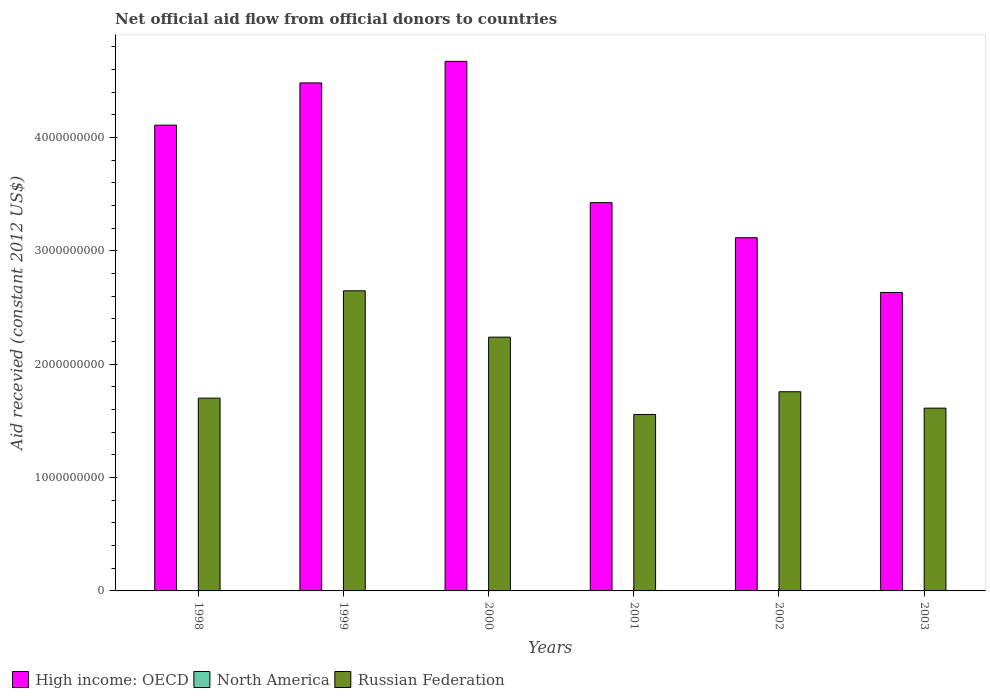Are the number of bars per tick equal to the number of legend labels?
Your answer should be very brief. Yes. What is the total aid received in High income: OECD in 1999?
Give a very brief answer. 4.48e+09. Across all years, what is the maximum total aid received in North America?
Offer a terse response. 7.40e+05. In which year was the total aid received in Russian Federation maximum?
Provide a short and direct response. 1999. In which year was the total aid received in Russian Federation minimum?
Your response must be concise. 2001. What is the total total aid received in North America in the graph?
Give a very brief answer. 1.09e+06. What is the difference between the total aid received in Russian Federation in 2002 and the total aid received in High income: OECD in 1999?
Offer a very short reply. -2.73e+09. What is the average total aid received in North America per year?
Give a very brief answer. 1.82e+05. In the year 1998, what is the difference between the total aid received in Russian Federation and total aid received in North America?
Make the answer very short. 1.70e+09. In how many years, is the total aid received in Russian Federation greater than 4000000000 US$?
Make the answer very short. 0. What is the ratio of the total aid received in Russian Federation in 1999 to that in 2000?
Your answer should be very brief. 1.18. What is the difference between the highest and the second highest total aid received in North America?
Make the answer very short. 6.10e+05. What is the difference between the highest and the lowest total aid received in High income: OECD?
Your answer should be compact. 2.04e+09. What does the 3rd bar from the left in 1999 represents?
Provide a succinct answer. Russian Federation. How many bars are there?
Ensure brevity in your answer.  18. Are all the bars in the graph horizontal?
Provide a succinct answer. No. What is the difference between two consecutive major ticks on the Y-axis?
Provide a succinct answer. 1.00e+09. Does the graph contain any zero values?
Offer a terse response. No. Where does the legend appear in the graph?
Offer a terse response. Bottom left. What is the title of the graph?
Give a very brief answer. Net official aid flow from official donors to countries. What is the label or title of the Y-axis?
Keep it short and to the point. Aid recevied (constant 2012 US$). What is the Aid recevied (constant 2012 US$) in High income: OECD in 1998?
Your answer should be very brief. 4.11e+09. What is the Aid recevied (constant 2012 US$) in North America in 1998?
Make the answer very short. 7.40e+05. What is the Aid recevied (constant 2012 US$) of Russian Federation in 1998?
Offer a terse response. 1.70e+09. What is the Aid recevied (constant 2012 US$) in High income: OECD in 1999?
Your answer should be compact. 4.48e+09. What is the Aid recevied (constant 2012 US$) of North America in 1999?
Your answer should be compact. 1.30e+05. What is the Aid recevied (constant 2012 US$) of Russian Federation in 1999?
Your answer should be compact. 2.65e+09. What is the Aid recevied (constant 2012 US$) of High income: OECD in 2000?
Your answer should be compact. 4.67e+09. What is the Aid recevied (constant 2012 US$) of North America in 2000?
Give a very brief answer. 1.10e+05. What is the Aid recevied (constant 2012 US$) in Russian Federation in 2000?
Provide a short and direct response. 2.24e+09. What is the Aid recevied (constant 2012 US$) in High income: OECD in 2001?
Offer a very short reply. 3.43e+09. What is the Aid recevied (constant 2012 US$) of Russian Federation in 2001?
Your answer should be very brief. 1.56e+09. What is the Aid recevied (constant 2012 US$) of High income: OECD in 2002?
Your response must be concise. 3.12e+09. What is the Aid recevied (constant 2012 US$) of North America in 2002?
Offer a terse response. 3.00e+04. What is the Aid recevied (constant 2012 US$) in Russian Federation in 2002?
Make the answer very short. 1.76e+09. What is the Aid recevied (constant 2012 US$) of High income: OECD in 2003?
Your response must be concise. 2.63e+09. What is the Aid recevied (constant 2012 US$) of Russian Federation in 2003?
Make the answer very short. 1.61e+09. Across all years, what is the maximum Aid recevied (constant 2012 US$) in High income: OECD?
Keep it short and to the point. 4.67e+09. Across all years, what is the maximum Aid recevied (constant 2012 US$) of North America?
Your answer should be compact. 7.40e+05. Across all years, what is the maximum Aid recevied (constant 2012 US$) of Russian Federation?
Offer a terse response. 2.65e+09. Across all years, what is the minimum Aid recevied (constant 2012 US$) in High income: OECD?
Make the answer very short. 2.63e+09. Across all years, what is the minimum Aid recevied (constant 2012 US$) of Russian Federation?
Provide a short and direct response. 1.56e+09. What is the total Aid recevied (constant 2012 US$) in High income: OECD in the graph?
Give a very brief answer. 2.24e+1. What is the total Aid recevied (constant 2012 US$) in North America in the graph?
Offer a very short reply. 1.09e+06. What is the total Aid recevied (constant 2012 US$) in Russian Federation in the graph?
Keep it short and to the point. 1.15e+1. What is the difference between the Aid recevied (constant 2012 US$) in High income: OECD in 1998 and that in 1999?
Provide a succinct answer. -3.73e+08. What is the difference between the Aid recevied (constant 2012 US$) in Russian Federation in 1998 and that in 1999?
Provide a short and direct response. -9.47e+08. What is the difference between the Aid recevied (constant 2012 US$) of High income: OECD in 1998 and that in 2000?
Provide a succinct answer. -5.63e+08. What is the difference between the Aid recevied (constant 2012 US$) of North America in 1998 and that in 2000?
Give a very brief answer. 6.30e+05. What is the difference between the Aid recevied (constant 2012 US$) in Russian Federation in 1998 and that in 2000?
Give a very brief answer. -5.38e+08. What is the difference between the Aid recevied (constant 2012 US$) of High income: OECD in 1998 and that in 2001?
Your response must be concise. 6.84e+08. What is the difference between the Aid recevied (constant 2012 US$) in North America in 1998 and that in 2001?
Provide a short and direct response. 7.00e+05. What is the difference between the Aid recevied (constant 2012 US$) in Russian Federation in 1998 and that in 2001?
Your response must be concise. 1.44e+08. What is the difference between the Aid recevied (constant 2012 US$) in High income: OECD in 1998 and that in 2002?
Offer a very short reply. 9.93e+08. What is the difference between the Aid recevied (constant 2012 US$) in North America in 1998 and that in 2002?
Your response must be concise. 7.10e+05. What is the difference between the Aid recevied (constant 2012 US$) in Russian Federation in 1998 and that in 2002?
Provide a short and direct response. -5.68e+07. What is the difference between the Aid recevied (constant 2012 US$) of High income: OECD in 1998 and that in 2003?
Keep it short and to the point. 1.48e+09. What is the difference between the Aid recevied (constant 2012 US$) of Russian Federation in 1998 and that in 2003?
Your answer should be compact. 8.80e+07. What is the difference between the Aid recevied (constant 2012 US$) of High income: OECD in 1999 and that in 2000?
Offer a terse response. -1.90e+08. What is the difference between the Aid recevied (constant 2012 US$) in North America in 1999 and that in 2000?
Make the answer very short. 2.00e+04. What is the difference between the Aid recevied (constant 2012 US$) of Russian Federation in 1999 and that in 2000?
Keep it short and to the point. 4.09e+08. What is the difference between the Aid recevied (constant 2012 US$) of High income: OECD in 1999 and that in 2001?
Offer a terse response. 1.06e+09. What is the difference between the Aid recevied (constant 2012 US$) of Russian Federation in 1999 and that in 2001?
Your response must be concise. 1.09e+09. What is the difference between the Aid recevied (constant 2012 US$) in High income: OECD in 1999 and that in 2002?
Keep it short and to the point. 1.37e+09. What is the difference between the Aid recevied (constant 2012 US$) of North America in 1999 and that in 2002?
Provide a succinct answer. 1.00e+05. What is the difference between the Aid recevied (constant 2012 US$) in Russian Federation in 1999 and that in 2002?
Provide a succinct answer. 8.90e+08. What is the difference between the Aid recevied (constant 2012 US$) in High income: OECD in 1999 and that in 2003?
Your answer should be very brief. 1.85e+09. What is the difference between the Aid recevied (constant 2012 US$) of North America in 1999 and that in 2003?
Your answer should be compact. 9.00e+04. What is the difference between the Aid recevied (constant 2012 US$) in Russian Federation in 1999 and that in 2003?
Ensure brevity in your answer.  1.04e+09. What is the difference between the Aid recevied (constant 2012 US$) of High income: OECD in 2000 and that in 2001?
Your answer should be very brief. 1.25e+09. What is the difference between the Aid recevied (constant 2012 US$) in North America in 2000 and that in 2001?
Your answer should be compact. 7.00e+04. What is the difference between the Aid recevied (constant 2012 US$) of Russian Federation in 2000 and that in 2001?
Your response must be concise. 6.83e+08. What is the difference between the Aid recevied (constant 2012 US$) of High income: OECD in 2000 and that in 2002?
Keep it short and to the point. 1.56e+09. What is the difference between the Aid recevied (constant 2012 US$) of North America in 2000 and that in 2002?
Offer a very short reply. 8.00e+04. What is the difference between the Aid recevied (constant 2012 US$) of Russian Federation in 2000 and that in 2002?
Offer a very short reply. 4.82e+08. What is the difference between the Aid recevied (constant 2012 US$) of High income: OECD in 2000 and that in 2003?
Your answer should be compact. 2.04e+09. What is the difference between the Aid recevied (constant 2012 US$) in North America in 2000 and that in 2003?
Provide a short and direct response. 7.00e+04. What is the difference between the Aid recevied (constant 2012 US$) of Russian Federation in 2000 and that in 2003?
Make the answer very short. 6.26e+08. What is the difference between the Aid recevied (constant 2012 US$) in High income: OECD in 2001 and that in 2002?
Your response must be concise. 3.10e+08. What is the difference between the Aid recevied (constant 2012 US$) of Russian Federation in 2001 and that in 2002?
Your answer should be compact. -2.01e+08. What is the difference between the Aid recevied (constant 2012 US$) of High income: OECD in 2001 and that in 2003?
Provide a succinct answer. 7.93e+08. What is the difference between the Aid recevied (constant 2012 US$) of Russian Federation in 2001 and that in 2003?
Your answer should be very brief. -5.60e+07. What is the difference between the Aid recevied (constant 2012 US$) in High income: OECD in 2002 and that in 2003?
Offer a terse response. 4.83e+08. What is the difference between the Aid recevied (constant 2012 US$) of Russian Federation in 2002 and that in 2003?
Give a very brief answer. 1.45e+08. What is the difference between the Aid recevied (constant 2012 US$) of High income: OECD in 1998 and the Aid recevied (constant 2012 US$) of North America in 1999?
Your answer should be very brief. 4.11e+09. What is the difference between the Aid recevied (constant 2012 US$) in High income: OECD in 1998 and the Aid recevied (constant 2012 US$) in Russian Federation in 1999?
Your answer should be very brief. 1.46e+09. What is the difference between the Aid recevied (constant 2012 US$) of North America in 1998 and the Aid recevied (constant 2012 US$) of Russian Federation in 1999?
Make the answer very short. -2.65e+09. What is the difference between the Aid recevied (constant 2012 US$) of High income: OECD in 1998 and the Aid recevied (constant 2012 US$) of North America in 2000?
Give a very brief answer. 4.11e+09. What is the difference between the Aid recevied (constant 2012 US$) in High income: OECD in 1998 and the Aid recevied (constant 2012 US$) in Russian Federation in 2000?
Keep it short and to the point. 1.87e+09. What is the difference between the Aid recevied (constant 2012 US$) of North America in 1998 and the Aid recevied (constant 2012 US$) of Russian Federation in 2000?
Offer a very short reply. -2.24e+09. What is the difference between the Aid recevied (constant 2012 US$) of High income: OECD in 1998 and the Aid recevied (constant 2012 US$) of North America in 2001?
Your response must be concise. 4.11e+09. What is the difference between the Aid recevied (constant 2012 US$) of High income: OECD in 1998 and the Aid recevied (constant 2012 US$) of Russian Federation in 2001?
Keep it short and to the point. 2.55e+09. What is the difference between the Aid recevied (constant 2012 US$) in North America in 1998 and the Aid recevied (constant 2012 US$) in Russian Federation in 2001?
Keep it short and to the point. -1.56e+09. What is the difference between the Aid recevied (constant 2012 US$) of High income: OECD in 1998 and the Aid recevied (constant 2012 US$) of North America in 2002?
Your response must be concise. 4.11e+09. What is the difference between the Aid recevied (constant 2012 US$) of High income: OECD in 1998 and the Aid recevied (constant 2012 US$) of Russian Federation in 2002?
Ensure brevity in your answer.  2.35e+09. What is the difference between the Aid recevied (constant 2012 US$) in North America in 1998 and the Aid recevied (constant 2012 US$) in Russian Federation in 2002?
Give a very brief answer. -1.76e+09. What is the difference between the Aid recevied (constant 2012 US$) of High income: OECD in 1998 and the Aid recevied (constant 2012 US$) of North America in 2003?
Keep it short and to the point. 4.11e+09. What is the difference between the Aid recevied (constant 2012 US$) of High income: OECD in 1998 and the Aid recevied (constant 2012 US$) of Russian Federation in 2003?
Make the answer very short. 2.50e+09. What is the difference between the Aid recevied (constant 2012 US$) in North America in 1998 and the Aid recevied (constant 2012 US$) in Russian Federation in 2003?
Offer a terse response. -1.61e+09. What is the difference between the Aid recevied (constant 2012 US$) of High income: OECD in 1999 and the Aid recevied (constant 2012 US$) of North America in 2000?
Give a very brief answer. 4.48e+09. What is the difference between the Aid recevied (constant 2012 US$) in High income: OECD in 1999 and the Aid recevied (constant 2012 US$) in Russian Federation in 2000?
Your answer should be compact. 2.24e+09. What is the difference between the Aid recevied (constant 2012 US$) in North America in 1999 and the Aid recevied (constant 2012 US$) in Russian Federation in 2000?
Keep it short and to the point. -2.24e+09. What is the difference between the Aid recevied (constant 2012 US$) of High income: OECD in 1999 and the Aid recevied (constant 2012 US$) of North America in 2001?
Make the answer very short. 4.48e+09. What is the difference between the Aid recevied (constant 2012 US$) of High income: OECD in 1999 and the Aid recevied (constant 2012 US$) of Russian Federation in 2001?
Give a very brief answer. 2.93e+09. What is the difference between the Aid recevied (constant 2012 US$) of North America in 1999 and the Aid recevied (constant 2012 US$) of Russian Federation in 2001?
Keep it short and to the point. -1.56e+09. What is the difference between the Aid recevied (constant 2012 US$) of High income: OECD in 1999 and the Aid recevied (constant 2012 US$) of North America in 2002?
Give a very brief answer. 4.48e+09. What is the difference between the Aid recevied (constant 2012 US$) of High income: OECD in 1999 and the Aid recevied (constant 2012 US$) of Russian Federation in 2002?
Offer a terse response. 2.73e+09. What is the difference between the Aid recevied (constant 2012 US$) of North America in 1999 and the Aid recevied (constant 2012 US$) of Russian Federation in 2002?
Provide a short and direct response. -1.76e+09. What is the difference between the Aid recevied (constant 2012 US$) of High income: OECD in 1999 and the Aid recevied (constant 2012 US$) of North America in 2003?
Provide a succinct answer. 4.48e+09. What is the difference between the Aid recevied (constant 2012 US$) in High income: OECD in 1999 and the Aid recevied (constant 2012 US$) in Russian Federation in 2003?
Provide a succinct answer. 2.87e+09. What is the difference between the Aid recevied (constant 2012 US$) of North America in 1999 and the Aid recevied (constant 2012 US$) of Russian Federation in 2003?
Offer a terse response. -1.61e+09. What is the difference between the Aid recevied (constant 2012 US$) in High income: OECD in 2000 and the Aid recevied (constant 2012 US$) in North America in 2001?
Your answer should be compact. 4.67e+09. What is the difference between the Aid recevied (constant 2012 US$) in High income: OECD in 2000 and the Aid recevied (constant 2012 US$) in Russian Federation in 2001?
Provide a succinct answer. 3.12e+09. What is the difference between the Aid recevied (constant 2012 US$) of North America in 2000 and the Aid recevied (constant 2012 US$) of Russian Federation in 2001?
Provide a succinct answer. -1.56e+09. What is the difference between the Aid recevied (constant 2012 US$) of High income: OECD in 2000 and the Aid recevied (constant 2012 US$) of North America in 2002?
Your response must be concise. 4.67e+09. What is the difference between the Aid recevied (constant 2012 US$) in High income: OECD in 2000 and the Aid recevied (constant 2012 US$) in Russian Federation in 2002?
Ensure brevity in your answer.  2.92e+09. What is the difference between the Aid recevied (constant 2012 US$) in North America in 2000 and the Aid recevied (constant 2012 US$) in Russian Federation in 2002?
Provide a short and direct response. -1.76e+09. What is the difference between the Aid recevied (constant 2012 US$) in High income: OECD in 2000 and the Aid recevied (constant 2012 US$) in North America in 2003?
Provide a short and direct response. 4.67e+09. What is the difference between the Aid recevied (constant 2012 US$) in High income: OECD in 2000 and the Aid recevied (constant 2012 US$) in Russian Federation in 2003?
Provide a short and direct response. 3.06e+09. What is the difference between the Aid recevied (constant 2012 US$) of North America in 2000 and the Aid recevied (constant 2012 US$) of Russian Federation in 2003?
Your answer should be very brief. -1.61e+09. What is the difference between the Aid recevied (constant 2012 US$) of High income: OECD in 2001 and the Aid recevied (constant 2012 US$) of North America in 2002?
Ensure brevity in your answer.  3.43e+09. What is the difference between the Aid recevied (constant 2012 US$) of High income: OECD in 2001 and the Aid recevied (constant 2012 US$) of Russian Federation in 2002?
Provide a short and direct response. 1.67e+09. What is the difference between the Aid recevied (constant 2012 US$) of North America in 2001 and the Aid recevied (constant 2012 US$) of Russian Federation in 2002?
Your answer should be very brief. -1.76e+09. What is the difference between the Aid recevied (constant 2012 US$) of High income: OECD in 2001 and the Aid recevied (constant 2012 US$) of North America in 2003?
Keep it short and to the point. 3.43e+09. What is the difference between the Aid recevied (constant 2012 US$) in High income: OECD in 2001 and the Aid recevied (constant 2012 US$) in Russian Federation in 2003?
Your answer should be compact. 1.81e+09. What is the difference between the Aid recevied (constant 2012 US$) in North America in 2001 and the Aid recevied (constant 2012 US$) in Russian Federation in 2003?
Your response must be concise. -1.61e+09. What is the difference between the Aid recevied (constant 2012 US$) of High income: OECD in 2002 and the Aid recevied (constant 2012 US$) of North America in 2003?
Offer a very short reply. 3.12e+09. What is the difference between the Aid recevied (constant 2012 US$) of High income: OECD in 2002 and the Aid recevied (constant 2012 US$) of Russian Federation in 2003?
Ensure brevity in your answer.  1.50e+09. What is the difference between the Aid recevied (constant 2012 US$) of North America in 2002 and the Aid recevied (constant 2012 US$) of Russian Federation in 2003?
Your answer should be compact. -1.61e+09. What is the average Aid recevied (constant 2012 US$) in High income: OECD per year?
Keep it short and to the point. 3.74e+09. What is the average Aid recevied (constant 2012 US$) of North America per year?
Your response must be concise. 1.82e+05. What is the average Aid recevied (constant 2012 US$) of Russian Federation per year?
Offer a terse response. 1.92e+09. In the year 1998, what is the difference between the Aid recevied (constant 2012 US$) of High income: OECD and Aid recevied (constant 2012 US$) of North America?
Offer a terse response. 4.11e+09. In the year 1998, what is the difference between the Aid recevied (constant 2012 US$) of High income: OECD and Aid recevied (constant 2012 US$) of Russian Federation?
Provide a succinct answer. 2.41e+09. In the year 1998, what is the difference between the Aid recevied (constant 2012 US$) of North America and Aid recevied (constant 2012 US$) of Russian Federation?
Offer a very short reply. -1.70e+09. In the year 1999, what is the difference between the Aid recevied (constant 2012 US$) in High income: OECD and Aid recevied (constant 2012 US$) in North America?
Offer a terse response. 4.48e+09. In the year 1999, what is the difference between the Aid recevied (constant 2012 US$) of High income: OECD and Aid recevied (constant 2012 US$) of Russian Federation?
Your answer should be very brief. 1.83e+09. In the year 1999, what is the difference between the Aid recevied (constant 2012 US$) of North America and Aid recevied (constant 2012 US$) of Russian Federation?
Offer a very short reply. -2.65e+09. In the year 2000, what is the difference between the Aid recevied (constant 2012 US$) of High income: OECD and Aid recevied (constant 2012 US$) of North America?
Offer a very short reply. 4.67e+09. In the year 2000, what is the difference between the Aid recevied (constant 2012 US$) in High income: OECD and Aid recevied (constant 2012 US$) in Russian Federation?
Provide a succinct answer. 2.43e+09. In the year 2000, what is the difference between the Aid recevied (constant 2012 US$) of North America and Aid recevied (constant 2012 US$) of Russian Federation?
Offer a terse response. -2.24e+09. In the year 2001, what is the difference between the Aid recevied (constant 2012 US$) of High income: OECD and Aid recevied (constant 2012 US$) of North America?
Offer a very short reply. 3.43e+09. In the year 2001, what is the difference between the Aid recevied (constant 2012 US$) in High income: OECD and Aid recevied (constant 2012 US$) in Russian Federation?
Your answer should be very brief. 1.87e+09. In the year 2001, what is the difference between the Aid recevied (constant 2012 US$) in North America and Aid recevied (constant 2012 US$) in Russian Federation?
Provide a short and direct response. -1.56e+09. In the year 2002, what is the difference between the Aid recevied (constant 2012 US$) of High income: OECD and Aid recevied (constant 2012 US$) of North America?
Your response must be concise. 3.12e+09. In the year 2002, what is the difference between the Aid recevied (constant 2012 US$) of High income: OECD and Aid recevied (constant 2012 US$) of Russian Federation?
Offer a very short reply. 1.36e+09. In the year 2002, what is the difference between the Aid recevied (constant 2012 US$) in North America and Aid recevied (constant 2012 US$) in Russian Federation?
Ensure brevity in your answer.  -1.76e+09. In the year 2003, what is the difference between the Aid recevied (constant 2012 US$) in High income: OECD and Aid recevied (constant 2012 US$) in North America?
Your response must be concise. 2.63e+09. In the year 2003, what is the difference between the Aid recevied (constant 2012 US$) in High income: OECD and Aid recevied (constant 2012 US$) in Russian Federation?
Give a very brief answer. 1.02e+09. In the year 2003, what is the difference between the Aid recevied (constant 2012 US$) in North America and Aid recevied (constant 2012 US$) in Russian Federation?
Provide a succinct answer. -1.61e+09. What is the ratio of the Aid recevied (constant 2012 US$) in High income: OECD in 1998 to that in 1999?
Your response must be concise. 0.92. What is the ratio of the Aid recevied (constant 2012 US$) of North America in 1998 to that in 1999?
Keep it short and to the point. 5.69. What is the ratio of the Aid recevied (constant 2012 US$) in Russian Federation in 1998 to that in 1999?
Your response must be concise. 0.64. What is the ratio of the Aid recevied (constant 2012 US$) of High income: OECD in 1998 to that in 2000?
Offer a very short reply. 0.88. What is the ratio of the Aid recevied (constant 2012 US$) in North America in 1998 to that in 2000?
Keep it short and to the point. 6.73. What is the ratio of the Aid recevied (constant 2012 US$) of Russian Federation in 1998 to that in 2000?
Your answer should be very brief. 0.76. What is the ratio of the Aid recevied (constant 2012 US$) of High income: OECD in 1998 to that in 2001?
Provide a succinct answer. 1.2. What is the ratio of the Aid recevied (constant 2012 US$) in Russian Federation in 1998 to that in 2001?
Ensure brevity in your answer.  1.09. What is the ratio of the Aid recevied (constant 2012 US$) in High income: OECD in 1998 to that in 2002?
Provide a succinct answer. 1.32. What is the ratio of the Aid recevied (constant 2012 US$) in North America in 1998 to that in 2002?
Make the answer very short. 24.67. What is the ratio of the Aid recevied (constant 2012 US$) in High income: OECD in 1998 to that in 2003?
Your answer should be very brief. 1.56. What is the ratio of the Aid recevied (constant 2012 US$) in North America in 1998 to that in 2003?
Ensure brevity in your answer.  18.5. What is the ratio of the Aid recevied (constant 2012 US$) in Russian Federation in 1998 to that in 2003?
Provide a succinct answer. 1.05. What is the ratio of the Aid recevied (constant 2012 US$) of High income: OECD in 1999 to that in 2000?
Give a very brief answer. 0.96. What is the ratio of the Aid recevied (constant 2012 US$) in North America in 1999 to that in 2000?
Offer a terse response. 1.18. What is the ratio of the Aid recevied (constant 2012 US$) of Russian Federation in 1999 to that in 2000?
Offer a very short reply. 1.18. What is the ratio of the Aid recevied (constant 2012 US$) of High income: OECD in 1999 to that in 2001?
Ensure brevity in your answer.  1.31. What is the ratio of the Aid recevied (constant 2012 US$) in North America in 1999 to that in 2001?
Provide a succinct answer. 3.25. What is the ratio of the Aid recevied (constant 2012 US$) in Russian Federation in 1999 to that in 2001?
Provide a succinct answer. 1.7. What is the ratio of the Aid recevied (constant 2012 US$) of High income: OECD in 1999 to that in 2002?
Your response must be concise. 1.44. What is the ratio of the Aid recevied (constant 2012 US$) in North America in 1999 to that in 2002?
Your answer should be very brief. 4.33. What is the ratio of the Aid recevied (constant 2012 US$) of Russian Federation in 1999 to that in 2002?
Your response must be concise. 1.51. What is the ratio of the Aid recevied (constant 2012 US$) in High income: OECD in 1999 to that in 2003?
Your answer should be very brief. 1.7. What is the ratio of the Aid recevied (constant 2012 US$) of Russian Federation in 1999 to that in 2003?
Your answer should be very brief. 1.64. What is the ratio of the Aid recevied (constant 2012 US$) of High income: OECD in 2000 to that in 2001?
Your response must be concise. 1.36. What is the ratio of the Aid recevied (constant 2012 US$) of North America in 2000 to that in 2001?
Provide a short and direct response. 2.75. What is the ratio of the Aid recevied (constant 2012 US$) in Russian Federation in 2000 to that in 2001?
Provide a short and direct response. 1.44. What is the ratio of the Aid recevied (constant 2012 US$) of High income: OECD in 2000 to that in 2002?
Offer a terse response. 1.5. What is the ratio of the Aid recevied (constant 2012 US$) in North America in 2000 to that in 2002?
Ensure brevity in your answer.  3.67. What is the ratio of the Aid recevied (constant 2012 US$) in Russian Federation in 2000 to that in 2002?
Your answer should be very brief. 1.27. What is the ratio of the Aid recevied (constant 2012 US$) in High income: OECD in 2000 to that in 2003?
Give a very brief answer. 1.77. What is the ratio of the Aid recevied (constant 2012 US$) of North America in 2000 to that in 2003?
Your answer should be compact. 2.75. What is the ratio of the Aid recevied (constant 2012 US$) in Russian Federation in 2000 to that in 2003?
Provide a short and direct response. 1.39. What is the ratio of the Aid recevied (constant 2012 US$) of High income: OECD in 2001 to that in 2002?
Make the answer very short. 1.1. What is the ratio of the Aid recevied (constant 2012 US$) in Russian Federation in 2001 to that in 2002?
Your answer should be compact. 0.89. What is the ratio of the Aid recevied (constant 2012 US$) of High income: OECD in 2001 to that in 2003?
Your answer should be compact. 1.3. What is the ratio of the Aid recevied (constant 2012 US$) in North America in 2001 to that in 2003?
Your response must be concise. 1. What is the ratio of the Aid recevied (constant 2012 US$) of Russian Federation in 2001 to that in 2003?
Your answer should be very brief. 0.97. What is the ratio of the Aid recevied (constant 2012 US$) in High income: OECD in 2002 to that in 2003?
Ensure brevity in your answer.  1.18. What is the ratio of the Aid recevied (constant 2012 US$) of North America in 2002 to that in 2003?
Give a very brief answer. 0.75. What is the ratio of the Aid recevied (constant 2012 US$) of Russian Federation in 2002 to that in 2003?
Offer a terse response. 1.09. What is the difference between the highest and the second highest Aid recevied (constant 2012 US$) in High income: OECD?
Keep it short and to the point. 1.90e+08. What is the difference between the highest and the second highest Aid recevied (constant 2012 US$) of Russian Federation?
Keep it short and to the point. 4.09e+08. What is the difference between the highest and the lowest Aid recevied (constant 2012 US$) of High income: OECD?
Keep it short and to the point. 2.04e+09. What is the difference between the highest and the lowest Aid recevied (constant 2012 US$) in North America?
Provide a short and direct response. 7.10e+05. What is the difference between the highest and the lowest Aid recevied (constant 2012 US$) of Russian Federation?
Give a very brief answer. 1.09e+09. 